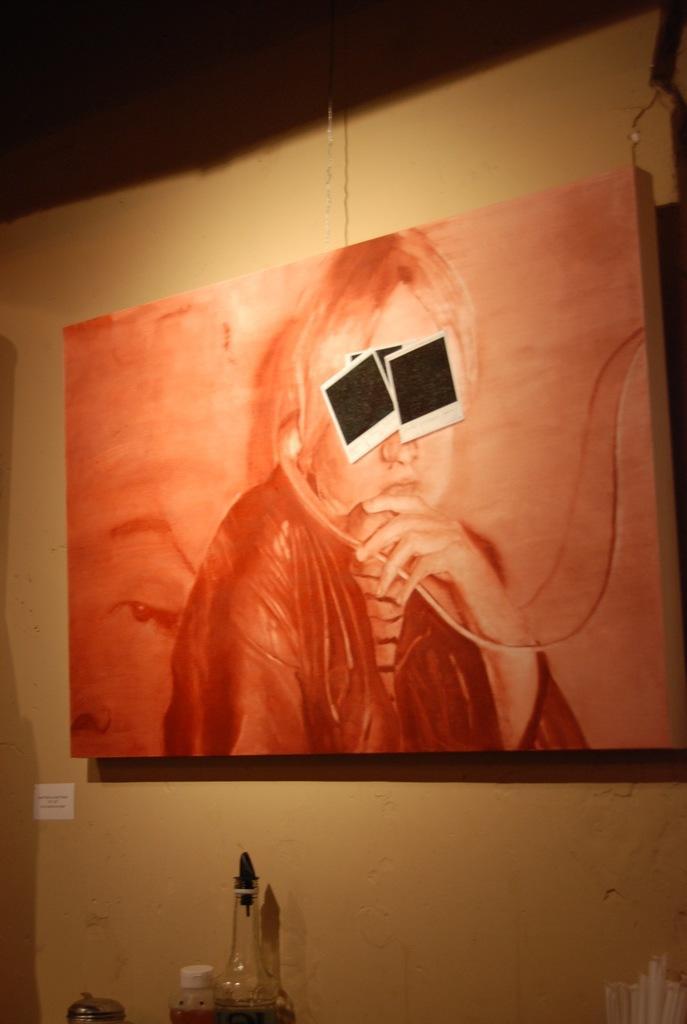Could you give a brief overview of what you see in this image? Here we can see a painting present on a wall and there are photographs struck to it and at the bottom we can see a bottle and a plastic jar present 